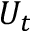<formula> <loc_0><loc_0><loc_500><loc_500>U _ { t }</formula> 